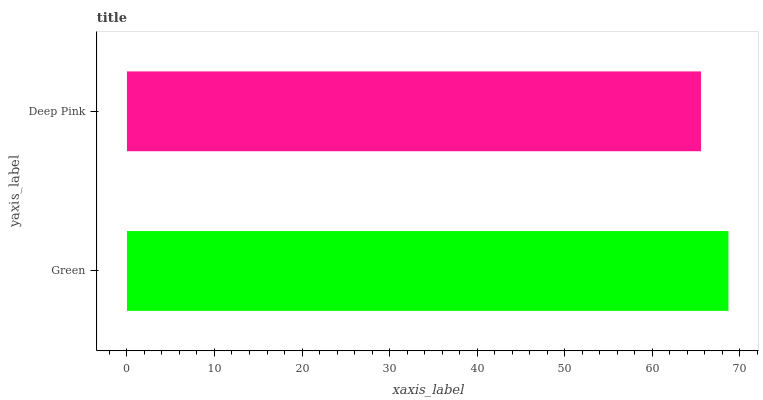Is Deep Pink the minimum?
Answer yes or no. Yes. Is Green the maximum?
Answer yes or no. Yes. Is Deep Pink the maximum?
Answer yes or no. No. Is Green greater than Deep Pink?
Answer yes or no. Yes. Is Deep Pink less than Green?
Answer yes or no. Yes. Is Deep Pink greater than Green?
Answer yes or no. No. Is Green less than Deep Pink?
Answer yes or no. No. Is Green the high median?
Answer yes or no. Yes. Is Deep Pink the low median?
Answer yes or no. Yes. Is Deep Pink the high median?
Answer yes or no. No. Is Green the low median?
Answer yes or no. No. 